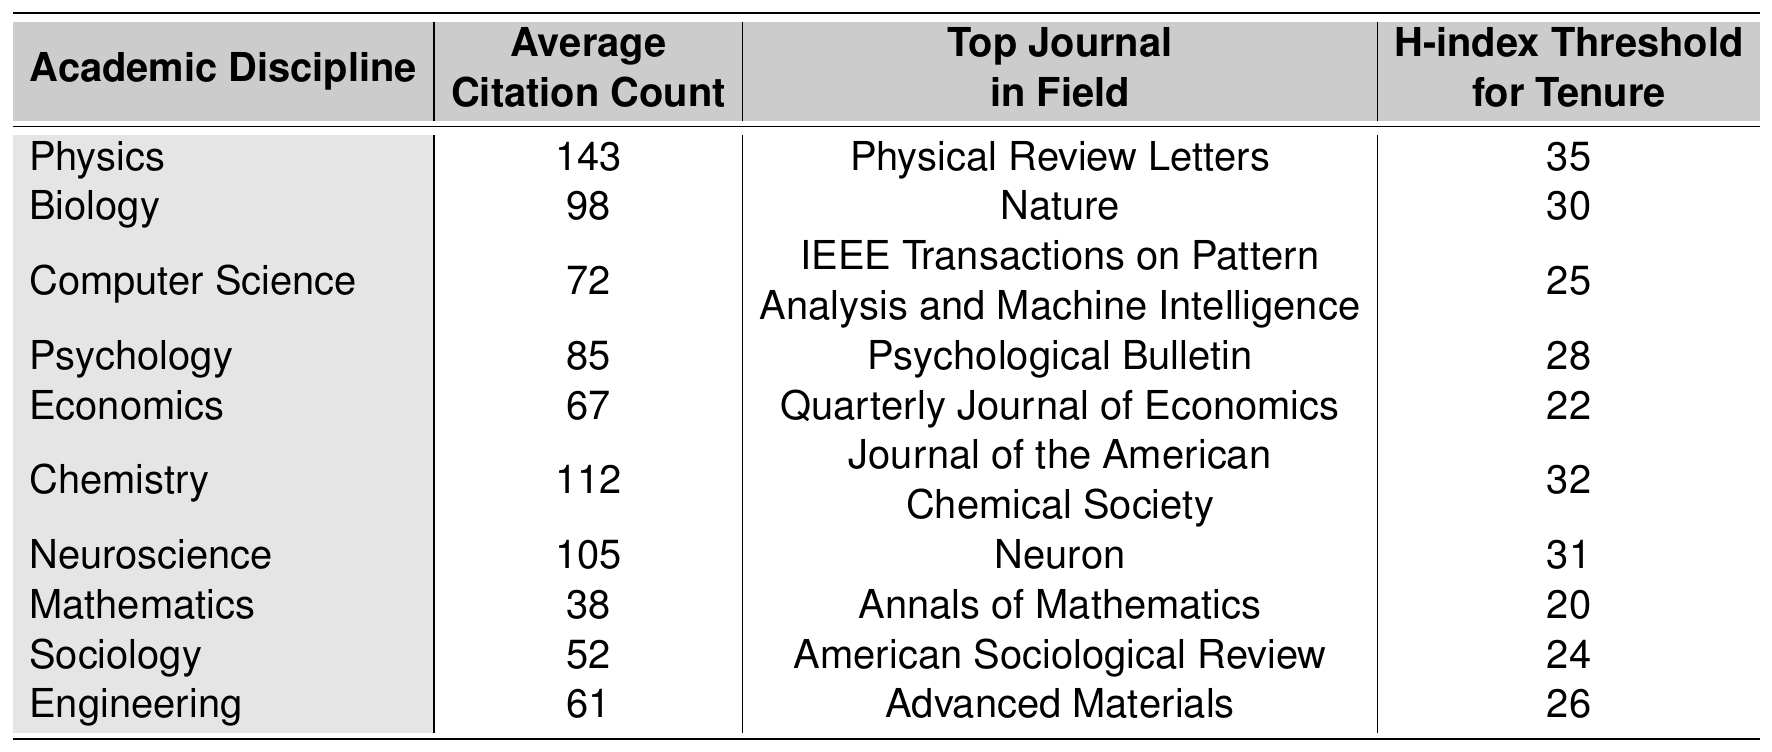What is the average citation count in the field of Biology? The table shows that the average citation count for Biology is listed directly in the corresponding row. The value is 98.
Answer: 98 Which academic discipline has the highest average citation count? By comparing the average citation counts listed, Physics has the highest with a count of 143, higher than any other discipline.
Answer: Physics What is the H-index threshold for tenure in the field of Chemistry? The H-index threshold for tenure associated with Chemistry is indicated in the table's respective row as 32.
Answer: 32 Is the top journal in Psychology ranked higher than the top journal in Sociology based on citation counts? The top journals are not ranked against each other in the data provided, but in terms of citation counts, Psychology's average is 85 while Sociology's is 52, implying that psychology is generally regarded higher than sociology.
Answer: Yes What is the difference in average citation counts between Physics and Economics? To find the difference, subtract the average citation count of Economics (67) from Physics (143): 143 - 67 = 76.
Answer: 76 Calculate the average citation count of the disciplines Engineering and Computer Science combined. The average citation counts for Engineering (61) and Computer Science (72) need to be summed up: 61 + 72 = 133. To find the average, divide by 2: 133 / 2 = 66.5.
Answer: 66.5 True or False: The top journal in the field of Neuroscience is “Nature.” The table states that the top journal in Neuroscience is "Neuron," not "Nature," which is associated with Biology. Therefore, this statement is false.
Answer: False What academic discipline has an H-index threshold of 35 for tenure? By examining the H-index thresholds listed for each discipline, only the field of Physics requires an H-index threshold of 35 for tenure.
Answer: Physics How many academic disciplines have an average citation count greater than 100? Looking through the average citation counts, Physics (143), Chemistry (112), and Neuroscience (105) all exceed 100 in the table. Therefore, there are three disciplines.
Answer: 3 What is the top journal in Computer Science? The table specifically lists the top journal in Computer Science as "IEEE Transactions on Pattern Analysis and Machine Intelligence."
Answer: IEEE Transactions on Pattern Analysis and Machine Intelligence 